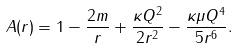Convert formula to latex. <formula><loc_0><loc_0><loc_500><loc_500>A ( r ) = 1 - \frac { 2 m } { r } + \frac { \kappa Q ^ { 2 } } { 2 r ^ { 2 } } - \frac { \kappa \mu Q ^ { 4 } } { 5 r ^ { 6 } } .</formula> 